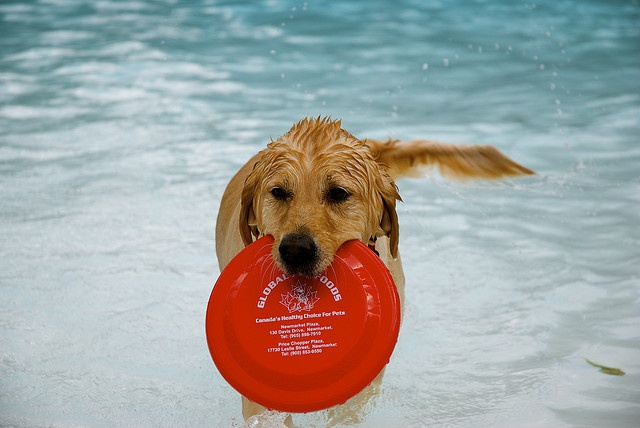Describe the objects in this image and their specific colors. I can see dog in teal, brown, olive, and tan tones and frisbee in teal, brown, and maroon tones in this image. 